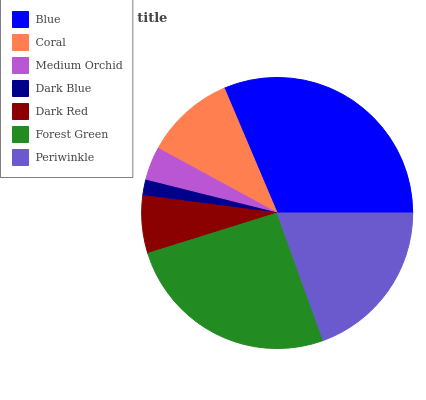Is Dark Blue the minimum?
Answer yes or no. Yes. Is Blue the maximum?
Answer yes or no. Yes. Is Coral the minimum?
Answer yes or no. No. Is Coral the maximum?
Answer yes or no. No. Is Blue greater than Coral?
Answer yes or no. Yes. Is Coral less than Blue?
Answer yes or no. Yes. Is Coral greater than Blue?
Answer yes or no. No. Is Blue less than Coral?
Answer yes or no. No. Is Coral the high median?
Answer yes or no. Yes. Is Coral the low median?
Answer yes or no. Yes. Is Dark Blue the high median?
Answer yes or no. No. Is Blue the low median?
Answer yes or no. No. 